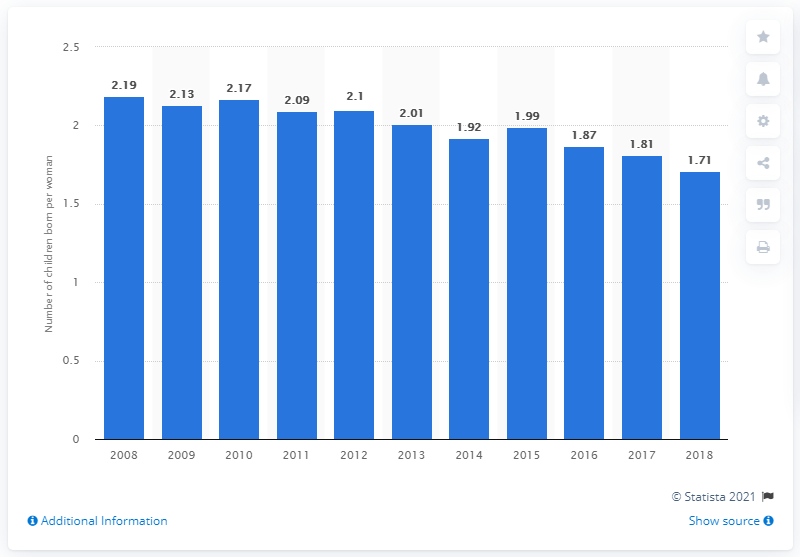Draw attention to some important aspects in this diagram. In 2018, the fertility rate in New Zealand was 1.71. 